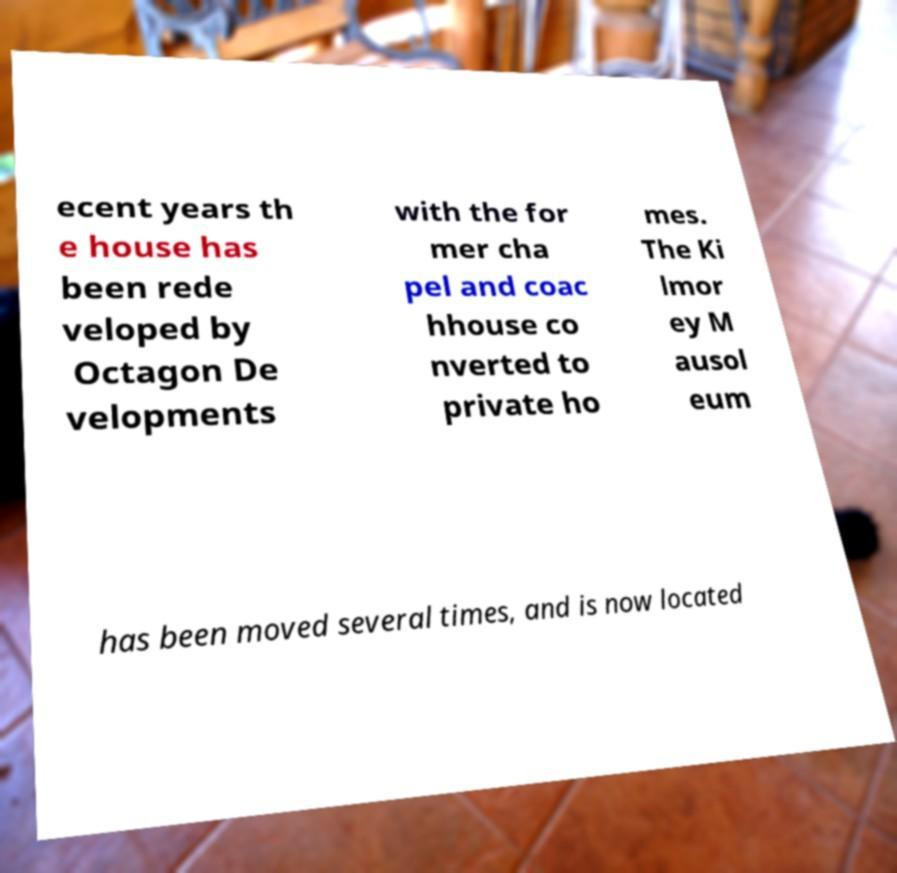For documentation purposes, I need the text within this image transcribed. Could you provide that? ecent years th e house has been rede veloped by Octagon De velopments with the for mer cha pel and coac hhouse co nverted to private ho mes. The Ki lmor ey M ausol eum has been moved several times, and is now located 